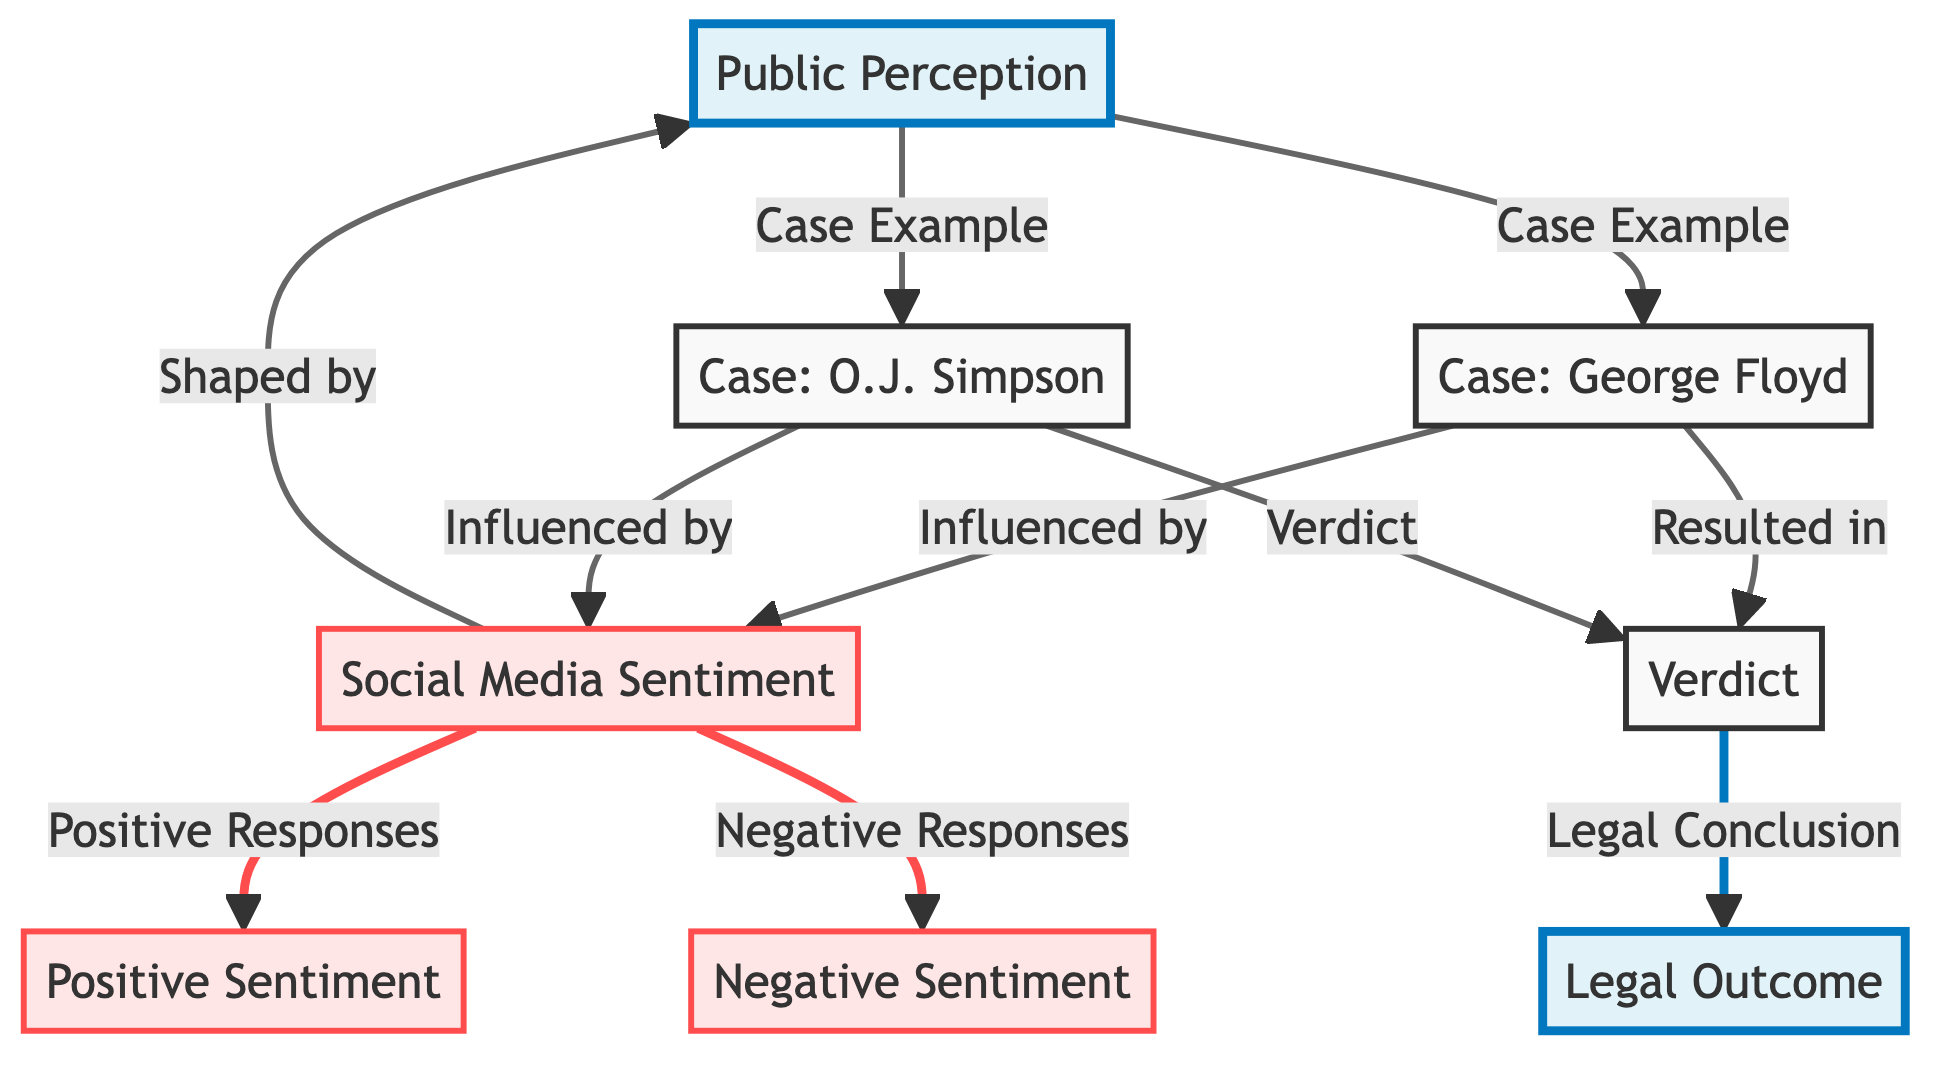What are the two main categories represented in the diagram? The diagram features two main categories, "Public Perception" and "Legal Outcome," which are highlighted as key nodes in the flowchart structure.
Answer: Public Perception, Legal Outcome Which case is associated with the social media sentiment in the diagram? The diagram highlights two specific cases: George Floyd and O.J. Simpson, both of which are linked to social media sentiment.
Answer: George Floyd, O.J. Simpson How does social media sentiment influence public perception in the diagram? The diagram indicates that social media sentiment shapes public perception, showing a directional flow from social media sentiment to public perception, highlighting their interrelationship.
Answer: Shaped by What kind of responses are linked to social media sentiment for the George Floyd case? The diagram specifies that social media sentiment for the George Floyd case is linked to both positive and negative responses, indicating a range of reactions.
Answer: Positive Responses, Negative Responses What does the verdict lead to in the context of legal outcomes? The diagram shows that the verdict results in a legal conclusion, clearly illustrating the final outcome based on the preceding legal processes and public influence.
Answer: Legal Conclusion What is the relationship between public perception and the cases presented? The diagram indicates that public perception serves as a reference point for both cases, directly linking them through the case examples presented in the flowchart.
Answer: Case Example How many types of sentiments are displayed in the diagram? The diagram clearly represents two types of sentiments associated with social media: positive sentiment and negative sentiment, signifying a dual perspective on public opinions.
Answer: Two Which case shows a connection between public perception and legal outcome? The diagram shows both the George Floyd and O.J. Simpson cases connecting public perception with the legal outcome, highlighting their influence on each other.
Answer: Both cases What is the visual representation of the influence of social media sentiment on the verdict? The diagram demonstrates that social media sentiment directly influences the verdict, connecting social media reactions to the legal conclusion reached in the cases analyzed.
Answer: Influenced by 